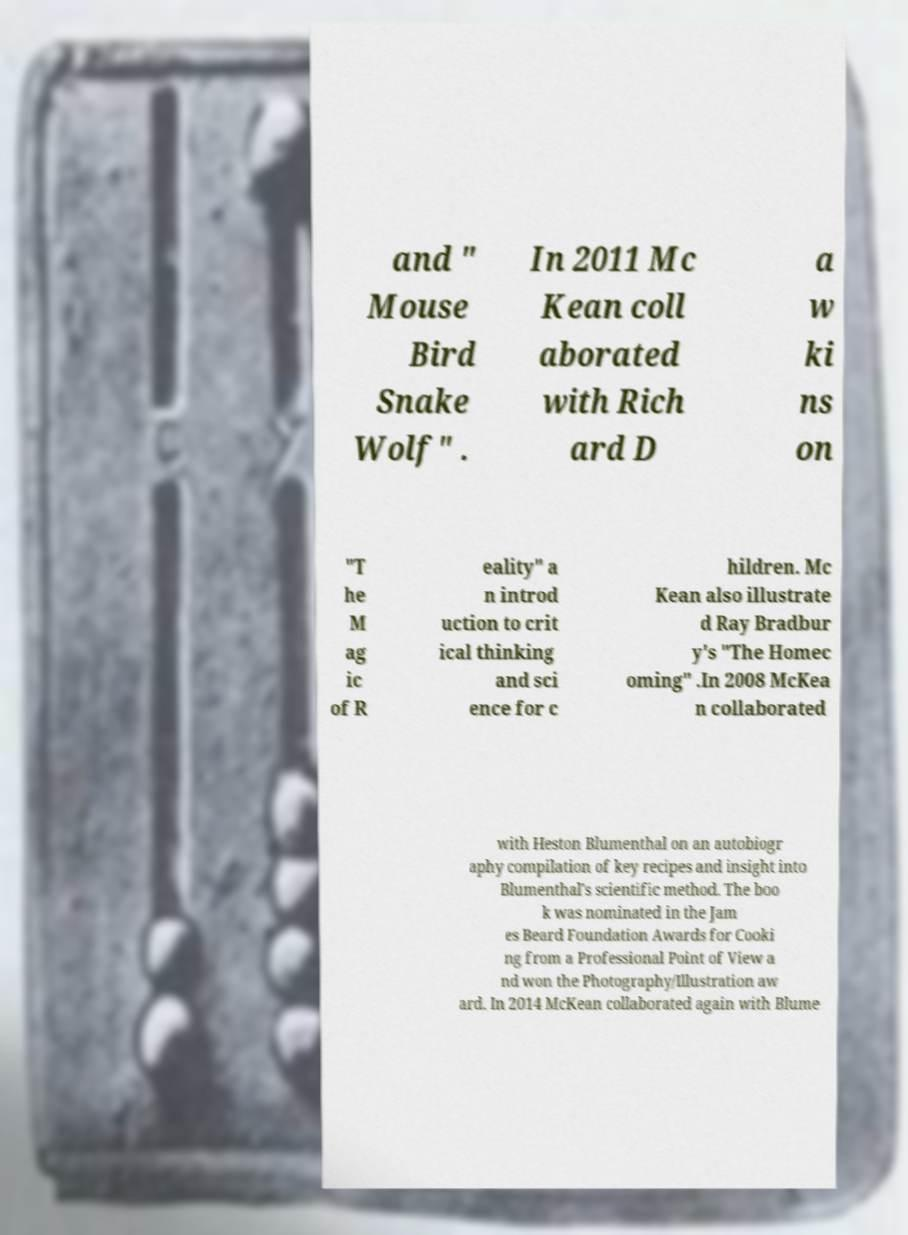There's text embedded in this image that I need extracted. Can you transcribe it verbatim? and " Mouse Bird Snake Wolf" . In 2011 Mc Kean coll aborated with Rich ard D a w ki ns on "T he M ag ic of R eality" a n introd uction to crit ical thinking and sci ence for c hildren. Mc Kean also illustrate d Ray Bradbur y's "The Homec oming" .In 2008 McKea n collaborated with Heston Blumenthal on an autobiogr aphy compilation of key recipes and insight into Blumenthal's scientific method. The boo k was nominated in the Jam es Beard Foundation Awards for Cooki ng from a Professional Point of View a nd won the Photography/Illustration aw ard. In 2014 McKean collaborated again with Blume 